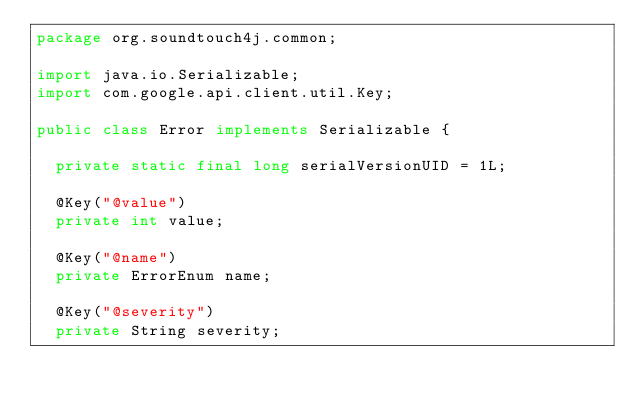<code> <loc_0><loc_0><loc_500><loc_500><_Java_>package org.soundtouch4j.common;

import java.io.Serializable;
import com.google.api.client.util.Key;

public class Error implements Serializable {

  private static final long serialVersionUID = 1L;

  @Key("@value")
  private int value;

  @Key("@name")
  private ErrorEnum name;

  @Key("@severity")
  private String severity;
</code> 